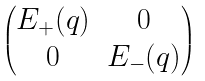Convert formula to latex. <formula><loc_0><loc_0><loc_500><loc_500>\begin{pmatrix} E _ { + } ( q ) & 0 \\ 0 & E _ { - } ( q ) \end{pmatrix}</formula> 